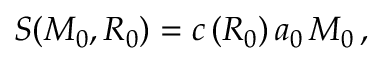<formula> <loc_0><loc_0><loc_500><loc_500>S ( M _ { 0 } , R _ { 0 } ) = c \, ( R _ { 0 } ) \, a _ { 0 } \, M _ { 0 } \, ,</formula> 